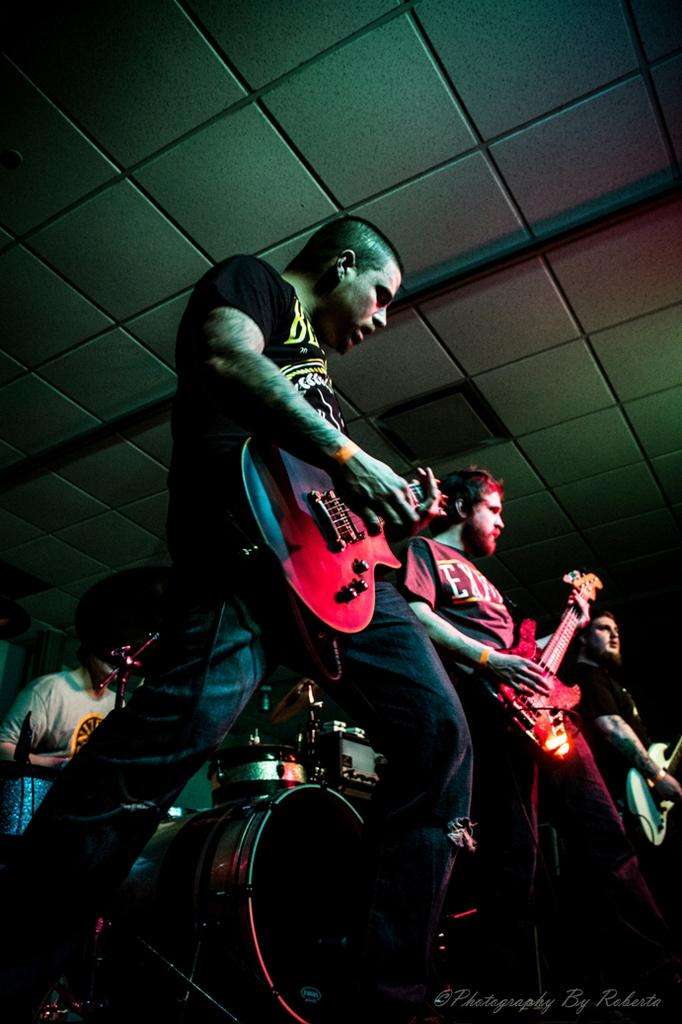How many people are in the image? There are four persons in the image. What are the three standing persons doing? They are playing a guitar. What is the person sitting doing? The person sitting is playing the drums. What can be seen in the background of the image? There is a ceiling visible in the background. What type of produce can be seen growing on the slope in the image? There is no produce or slope present in the image; it features four people playing musical instruments. 